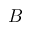Convert formula to latex. <formula><loc_0><loc_0><loc_500><loc_500>B</formula> 